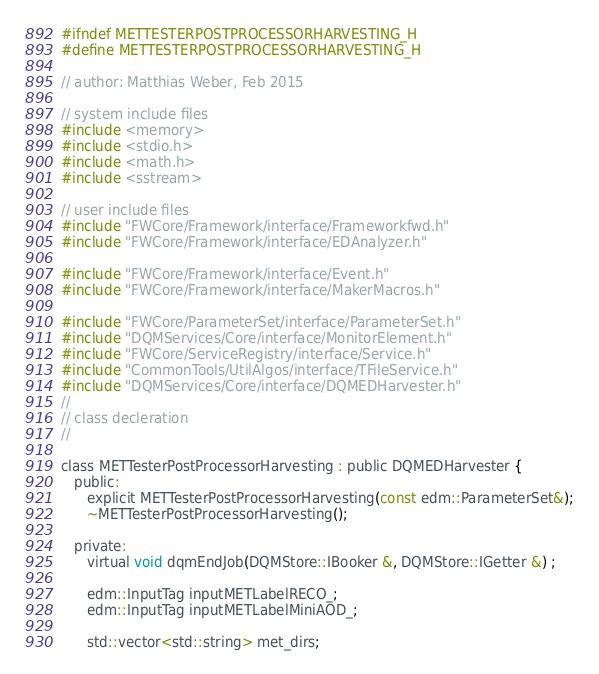<code> <loc_0><loc_0><loc_500><loc_500><_C_>#ifndef METTESTERPOSTPROCESSORHARVESTING_H
#define METTESTERPOSTPROCESSORHARVESTING_H

// author: Matthias Weber, Feb 2015

// system include files
#include <memory>
#include <stdio.h>
#include <math.h>
#include <sstream>

// user include files
#include "FWCore/Framework/interface/Frameworkfwd.h"
#include "FWCore/Framework/interface/EDAnalyzer.h"

#include "FWCore/Framework/interface/Event.h"
#include "FWCore/Framework/interface/MakerMacros.h"

#include "FWCore/ParameterSet/interface/ParameterSet.h"
#include "DQMServices/Core/interface/MonitorElement.h"
#include "FWCore/ServiceRegistry/interface/Service.h"
#include "CommonTools/UtilAlgos/interface/TFileService.h"
#include "DQMServices/Core/interface/DQMEDHarvester.h"
//
// class decleration
//

class METTesterPostProcessorHarvesting : public DQMEDHarvester {
   public:
      explicit METTesterPostProcessorHarvesting(const edm::ParameterSet&);
      ~METTesterPostProcessorHarvesting();

   private:
      virtual void dqmEndJob(DQMStore::IBooker &, DQMStore::IGetter &) ;

      edm::InputTag inputMETLabelRECO_;
      edm::InputTag inputMETLabelMiniAOD_;

      std::vector<std::string> met_dirs;
</code> 